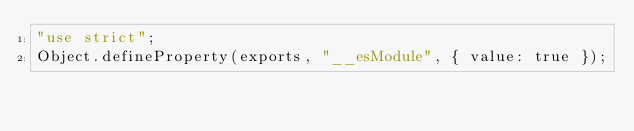Convert code to text. <code><loc_0><loc_0><loc_500><loc_500><_JavaScript_>"use strict";
Object.defineProperty(exports, "__esModule", { value: true });</code> 